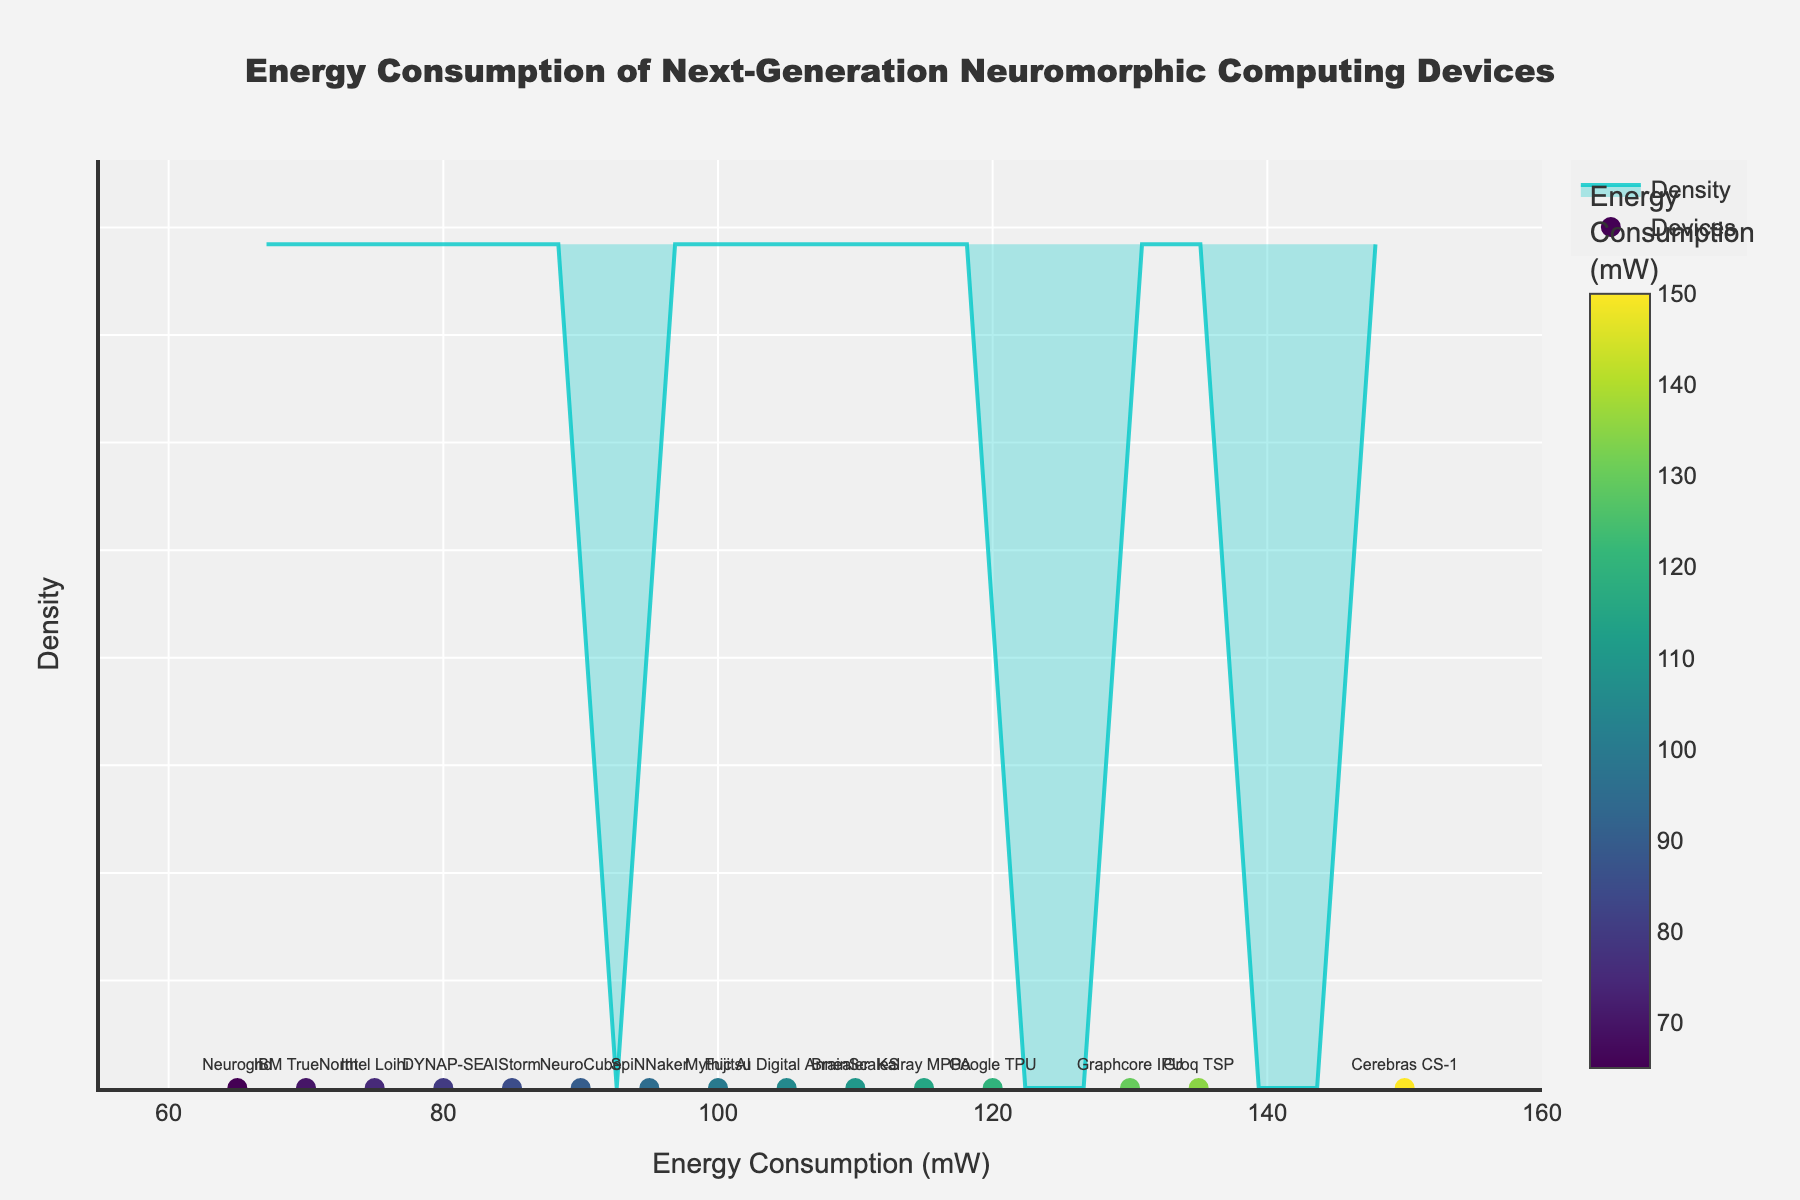How many devices are analyzed in the density plot? To determine the number of devices, count the number of unique data points represented by markers in the plot.
Answer: 15 Which device shows the highest energy consumption? Look for the marker with the highest value along the x-axis and identify its label.
Answer: Cerebras CS-1 What is the range of energy consumption for these neuromorphic computing devices? Find the minimum and maximum values along the x-axis where markers are present.
Answer: 65 mW to 150 mW Do most devices have energy consumption below 100 mW? Examine the density plot to see where the highest density of points is concentrated relative to the 100 mW mark.
Answer: Yes Which device has the closest energy consumption to the median? Sort the energy consumption values and find the middle one in the sorted list. Identify the device corresponding to this value.
Answer: NeuroCube How does the energy consumption of Intel Loihi compare to Neurogrid? Locate the x-axis values of Intel Loihi and Neurogrid, and directly compare the two values.
Answer: 75 mW is greater than 65 mW What is the approximate density of devices consuming around 85 mW of energy? Look at the density curve on the y-axis value corresponding to 85 mW on the x-axis.
Answer: Approximately 0.08 Between the median and the maximum energy consumption, which device consumes the closest to the halfway point? Calculate the halfway point between the median and the maximum energy consumption, check which device's consumption is nearest this value.
Answer: Fujitsu Digital Annealer What proportion of the devices have energy consumption above 100 mW? Count the number of devices with values greater than 100 mW and divide by the total number of devices.
Answer: 6 out of 15 Is the energy consumption distribution left-skewed or right-skewed? Analyze the shape of the density plot to observe where the bulk of the data points lie in relation to the peak and the tail on either side.
Answer: Right-skewed 